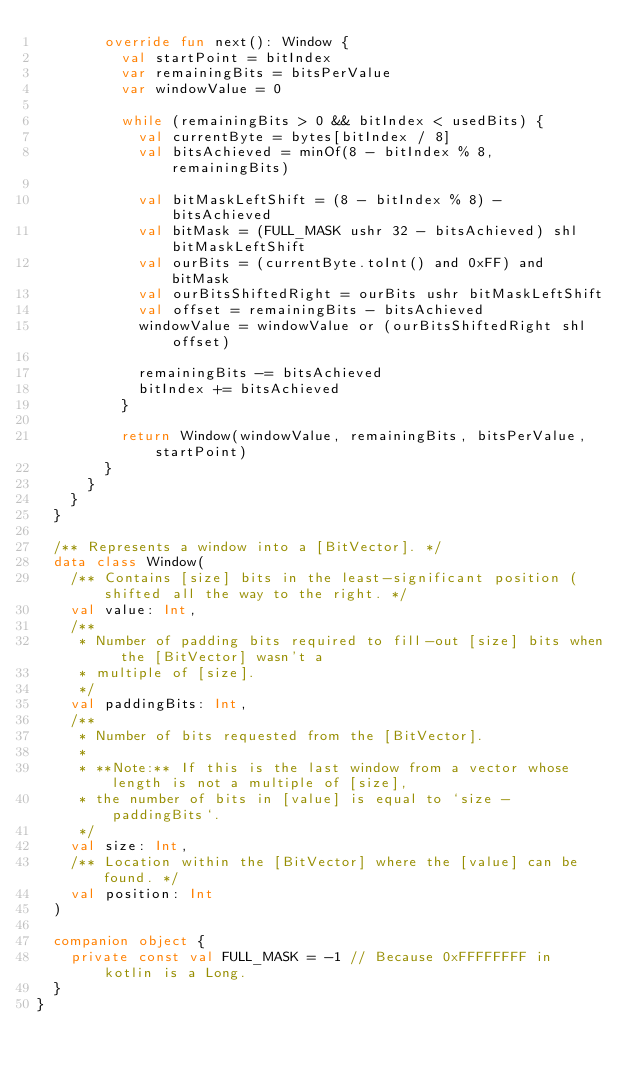<code> <loc_0><loc_0><loc_500><loc_500><_Kotlin_>        override fun next(): Window {
          val startPoint = bitIndex
          var remainingBits = bitsPerValue
          var windowValue = 0

          while (remainingBits > 0 && bitIndex < usedBits) {
            val currentByte = bytes[bitIndex / 8]
            val bitsAchieved = minOf(8 - bitIndex % 8, remainingBits)

            val bitMaskLeftShift = (8 - bitIndex % 8) - bitsAchieved
            val bitMask = (FULL_MASK ushr 32 - bitsAchieved) shl bitMaskLeftShift
            val ourBits = (currentByte.toInt() and 0xFF) and bitMask
            val ourBitsShiftedRight = ourBits ushr bitMaskLeftShift
            val offset = remainingBits - bitsAchieved
            windowValue = windowValue or (ourBitsShiftedRight shl offset)

            remainingBits -= bitsAchieved
            bitIndex += bitsAchieved
          }

          return Window(windowValue, remainingBits, bitsPerValue, startPoint)
        }
      }
    }
  }

  /** Represents a window into a [BitVector]. */
  data class Window(
    /** Contains [size] bits in the least-significant position (shifted all the way to the right. */
    val value: Int,
    /**
     * Number of padding bits required to fill-out [size] bits when the [BitVector] wasn't a
     * multiple of [size].
     */
    val paddingBits: Int,
    /**
     * Number of bits requested from the [BitVector].
     *
     * **Note:** If this is the last window from a vector whose length is not a multiple of [size],
     * the number of bits in [value] is equal to `size - paddingBits`.
     */
    val size: Int,
    /** Location within the [BitVector] where the [value] can be found. */
    val position: Int
  )

  companion object {
    private const val FULL_MASK = -1 // Because 0xFFFFFFFF in kotlin is a Long.
  }
}
</code> 